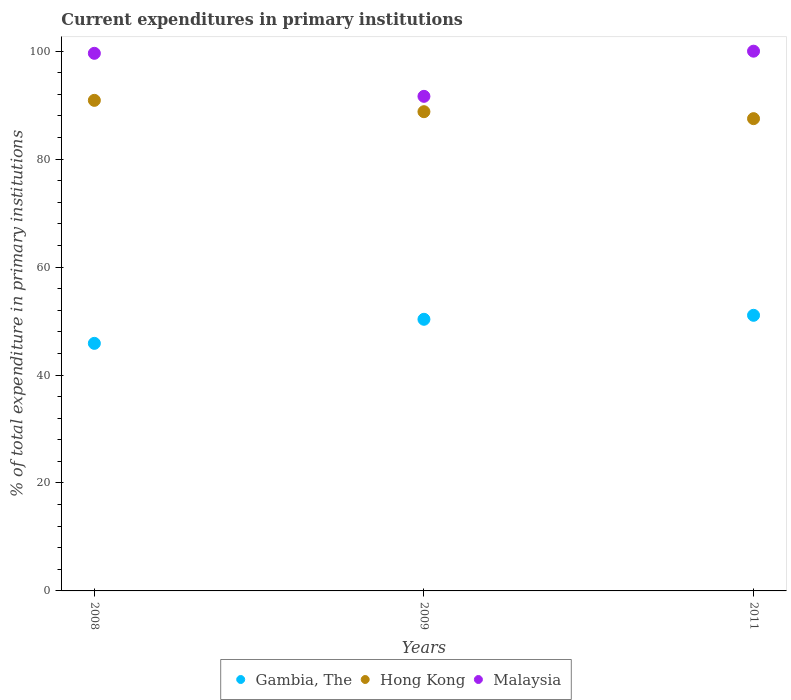How many different coloured dotlines are there?
Your response must be concise. 3. Is the number of dotlines equal to the number of legend labels?
Give a very brief answer. Yes. What is the current expenditures in primary institutions in Gambia, The in 2011?
Your response must be concise. 51.07. Across all years, what is the maximum current expenditures in primary institutions in Gambia, The?
Ensure brevity in your answer.  51.07. Across all years, what is the minimum current expenditures in primary institutions in Malaysia?
Your answer should be compact. 91.63. In which year was the current expenditures in primary institutions in Malaysia minimum?
Ensure brevity in your answer.  2009. What is the total current expenditures in primary institutions in Malaysia in the graph?
Provide a succinct answer. 291.24. What is the difference between the current expenditures in primary institutions in Gambia, The in 2008 and that in 2011?
Make the answer very short. -5.2. What is the difference between the current expenditures in primary institutions in Malaysia in 2011 and the current expenditures in primary institutions in Gambia, The in 2009?
Your answer should be very brief. 49.67. What is the average current expenditures in primary institutions in Gambia, The per year?
Make the answer very short. 49.09. In the year 2009, what is the difference between the current expenditures in primary institutions in Gambia, The and current expenditures in primary institutions in Hong Kong?
Ensure brevity in your answer.  -38.46. In how many years, is the current expenditures in primary institutions in Hong Kong greater than 92 %?
Provide a short and direct response. 0. What is the ratio of the current expenditures in primary institutions in Gambia, The in 2008 to that in 2011?
Provide a short and direct response. 0.9. Is the difference between the current expenditures in primary institutions in Gambia, The in 2009 and 2011 greater than the difference between the current expenditures in primary institutions in Hong Kong in 2009 and 2011?
Your answer should be very brief. No. What is the difference between the highest and the second highest current expenditures in primary institutions in Gambia, The?
Keep it short and to the point. 0.74. What is the difference between the highest and the lowest current expenditures in primary institutions in Gambia, The?
Provide a short and direct response. 5.2. In how many years, is the current expenditures in primary institutions in Gambia, The greater than the average current expenditures in primary institutions in Gambia, The taken over all years?
Offer a terse response. 2. Is the sum of the current expenditures in primary institutions in Gambia, The in 2008 and 2009 greater than the maximum current expenditures in primary institutions in Hong Kong across all years?
Provide a succinct answer. Yes. Is the current expenditures in primary institutions in Malaysia strictly greater than the current expenditures in primary institutions in Gambia, The over the years?
Your response must be concise. Yes. How many years are there in the graph?
Give a very brief answer. 3. What is the difference between two consecutive major ticks on the Y-axis?
Give a very brief answer. 20. Does the graph contain any zero values?
Provide a succinct answer. No. Where does the legend appear in the graph?
Offer a very short reply. Bottom center. What is the title of the graph?
Provide a short and direct response. Current expenditures in primary institutions. What is the label or title of the Y-axis?
Provide a short and direct response. % of total expenditure in primary institutions. What is the % of total expenditure in primary institutions in Gambia, The in 2008?
Your response must be concise. 45.87. What is the % of total expenditure in primary institutions in Hong Kong in 2008?
Your answer should be compact. 90.89. What is the % of total expenditure in primary institutions in Malaysia in 2008?
Offer a very short reply. 99.61. What is the % of total expenditure in primary institutions in Gambia, The in 2009?
Your response must be concise. 50.33. What is the % of total expenditure in primary institutions of Hong Kong in 2009?
Offer a terse response. 88.79. What is the % of total expenditure in primary institutions of Malaysia in 2009?
Make the answer very short. 91.63. What is the % of total expenditure in primary institutions of Gambia, The in 2011?
Offer a terse response. 51.07. What is the % of total expenditure in primary institutions of Hong Kong in 2011?
Your response must be concise. 87.5. Across all years, what is the maximum % of total expenditure in primary institutions of Gambia, The?
Offer a very short reply. 51.07. Across all years, what is the maximum % of total expenditure in primary institutions of Hong Kong?
Ensure brevity in your answer.  90.89. Across all years, what is the minimum % of total expenditure in primary institutions in Gambia, The?
Provide a succinct answer. 45.87. Across all years, what is the minimum % of total expenditure in primary institutions in Hong Kong?
Offer a terse response. 87.5. Across all years, what is the minimum % of total expenditure in primary institutions of Malaysia?
Provide a short and direct response. 91.63. What is the total % of total expenditure in primary institutions of Gambia, The in the graph?
Give a very brief answer. 147.26. What is the total % of total expenditure in primary institutions in Hong Kong in the graph?
Provide a short and direct response. 267.18. What is the total % of total expenditure in primary institutions in Malaysia in the graph?
Your answer should be compact. 291.24. What is the difference between the % of total expenditure in primary institutions in Gambia, The in 2008 and that in 2009?
Provide a succinct answer. -4.46. What is the difference between the % of total expenditure in primary institutions in Hong Kong in 2008 and that in 2009?
Give a very brief answer. 2.1. What is the difference between the % of total expenditure in primary institutions of Malaysia in 2008 and that in 2009?
Make the answer very short. 7.97. What is the difference between the % of total expenditure in primary institutions of Gambia, The in 2008 and that in 2011?
Give a very brief answer. -5.2. What is the difference between the % of total expenditure in primary institutions in Hong Kong in 2008 and that in 2011?
Keep it short and to the point. 3.39. What is the difference between the % of total expenditure in primary institutions in Malaysia in 2008 and that in 2011?
Your answer should be very brief. -0.39. What is the difference between the % of total expenditure in primary institutions of Gambia, The in 2009 and that in 2011?
Make the answer very short. -0.74. What is the difference between the % of total expenditure in primary institutions in Hong Kong in 2009 and that in 2011?
Offer a very short reply. 1.29. What is the difference between the % of total expenditure in primary institutions in Malaysia in 2009 and that in 2011?
Provide a short and direct response. -8.37. What is the difference between the % of total expenditure in primary institutions in Gambia, The in 2008 and the % of total expenditure in primary institutions in Hong Kong in 2009?
Ensure brevity in your answer.  -42.92. What is the difference between the % of total expenditure in primary institutions of Gambia, The in 2008 and the % of total expenditure in primary institutions of Malaysia in 2009?
Offer a very short reply. -45.77. What is the difference between the % of total expenditure in primary institutions of Hong Kong in 2008 and the % of total expenditure in primary institutions of Malaysia in 2009?
Provide a short and direct response. -0.74. What is the difference between the % of total expenditure in primary institutions in Gambia, The in 2008 and the % of total expenditure in primary institutions in Hong Kong in 2011?
Make the answer very short. -41.63. What is the difference between the % of total expenditure in primary institutions of Gambia, The in 2008 and the % of total expenditure in primary institutions of Malaysia in 2011?
Your answer should be very brief. -54.13. What is the difference between the % of total expenditure in primary institutions in Hong Kong in 2008 and the % of total expenditure in primary institutions in Malaysia in 2011?
Ensure brevity in your answer.  -9.11. What is the difference between the % of total expenditure in primary institutions in Gambia, The in 2009 and the % of total expenditure in primary institutions in Hong Kong in 2011?
Give a very brief answer. -37.18. What is the difference between the % of total expenditure in primary institutions of Gambia, The in 2009 and the % of total expenditure in primary institutions of Malaysia in 2011?
Your response must be concise. -49.67. What is the difference between the % of total expenditure in primary institutions of Hong Kong in 2009 and the % of total expenditure in primary institutions of Malaysia in 2011?
Give a very brief answer. -11.21. What is the average % of total expenditure in primary institutions in Gambia, The per year?
Provide a short and direct response. 49.09. What is the average % of total expenditure in primary institutions of Hong Kong per year?
Keep it short and to the point. 89.06. What is the average % of total expenditure in primary institutions in Malaysia per year?
Provide a short and direct response. 97.08. In the year 2008, what is the difference between the % of total expenditure in primary institutions in Gambia, The and % of total expenditure in primary institutions in Hong Kong?
Your answer should be compact. -45.02. In the year 2008, what is the difference between the % of total expenditure in primary institutions in Gambia, The and % of total expenditure in primary institutions in Malaysia?
Keep it short and to the point. -53.74. In the year 2008, what is the difference between the % of total expenditure in primary institutions in Hong Kong and % of total expenditure in primary institutions in Malaysia?
Your answer should be compact. -8.72. In the year 2009, what is the difference between the % of total expenditure in primary institutions in Gambia, The and % of total expenditure in primary institutions in Hong Kong?
Provide a succinct answer. -38.46. In the year 2009, what is the difference between the % of total expenditure in primary institutions of Gambia, The and % of total expenditure in primary institutions of Malaysia?
Provide a succinct answer. -41.31. In the year 2009, what is the difference between the % of total expenditure in primary institutions of Hong Kong and % of total expenditure in primary institutions of Malaysia?
Your answer should be very brief. -2.84. In the year 2011, what is the difference between the % of total expenditure in primary institutions in Gambia, The and % of total expenditure in primary institutions in Hong Kong?
Your answer should be very brief. -36.44. In the year 2011, what is the difference between the % of total expenditure in primary institutions in Gambia, The and % of total expenditure in primary institutions in Malaysia?
Your answer should be very brief. -48.93. In the year 2011, what is the difference between the % of total expenditure in primary institutions of Hong Kong and % of total expenditure in primary institutions of Malaysia?
Make the answer very short. -12.5. What is the ratio of the % of total expenditure in primary institutions in Gambia, The in 2008 to that in 2009?
Make the answer very short. 0.91. What is the ratio of the % of total expenditure in primary institutions of Hong Kong in 2008 to that in 2009?
Make the answer very short. 1.02. What is the ratio of the % of total expenditure in primary institutions in Malaysia in 2008 to that in 2009?
Offer a terse response. 1.09. What is the ratio of the % of total expenditure in primary institutions in Gambia, The in 2008 to that in 2011?
Provide a succinct answer. 0.9. What is the ratio of the % of total expenditure in primary institutions of Hong Kong in 2008 to that in 2011?
Give a very brief answer. 1.04. What is the ratio of the % of total expenditure in primary institutions of Gambia, The in 2009 to that in 2011?
Give a very brief answer. 0.99. What is the ratio of the % of total expenditure in primary institutions in Hong Kong in 2009 to that in 2011?
Offer a terse response. 1.01. What is the ratio of the % of total expenditure in primary institutions in Malaysia in 2009 to that in 2011?
Provide a short and direct response. 0.92. What is the difference between the highest and the second highest % of total expenditure in primary institutions of Gambia, The?
Offer a very short reply. 0.74. What is the difference between the highest and the second highest % of total expenditure in primary institutions in Hong Kong?
Your response must be concise. 2.1. What is the difference between the highest and the second highest % of total expenditure in primary institutions of Malaysia?
Give a very brief answer. 0.39. What is the difference between the highest and the lowest % of total expenditure in primary institutions of Gambia, The?
Make the answer very short. 5.2. What is the difference between the highest and the lowest % of total expenditure in primary institutions of Hong Kong?
Keep it short and to the point. 3.39. What is the difference between the highest and the lowest % of total expenditure in primary institutions of Malaysia?
Offer a very short reply. 8.37. 